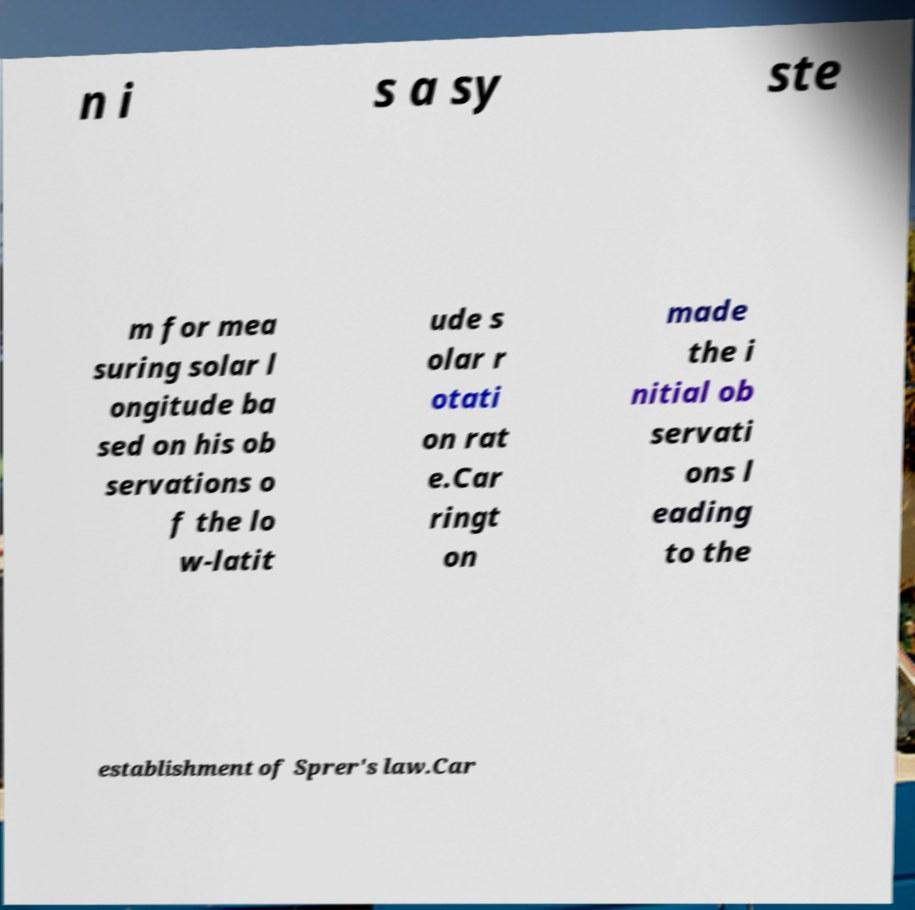Could you extract and type out the text from this image? n i s a sy ste m for mea suring solar l ongitude ba sed on his ob servations o f the lo w-latit ude s olar r otati on rat e.Car ringt on made the i nitial ob servati ons l eading to the establishment of Sprer's law.Car 